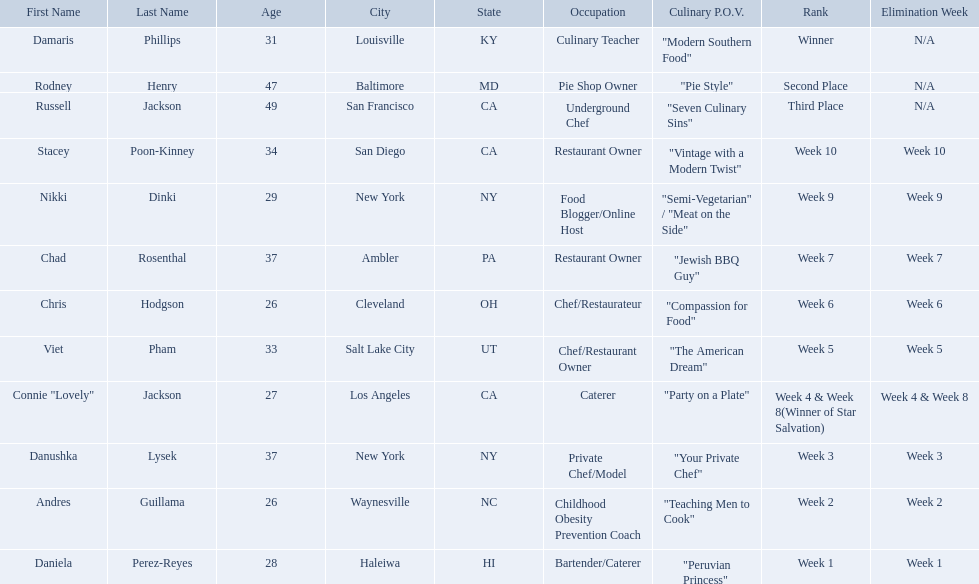Which food network star contestants are in their 20s? Nikki Dinki, Chris Hodgson, Connie "Lovely" Jackson, Andres Guillama, Daniela Perez-Reyes. Of these contestants, which one is the same age as chris hodgson? Andres Guillama. Who are all of the people listed? Damaris Phillips, Rodney Henry, Russell Jackson, Stacey Poon-Kinney, Nikki Dinki, Chad Rosenthal, Chris Hodgson, Viet Pham, Connie "Lovely" Jackson, Danushka Lysek, Andres Guillama, Daniela Perez-Reyes. How old are they? 31, 47, 49, 34, 29, 37, 26, 33, 27, 37, 26, 28. Along with chris hodgson, which other person is 26 years old? Andres Guillama. Who are the contestants? Damaris Phillips, 31, Rodney Henry, 47, Russell Jackson, 49, Stacey Poon-Kinney, 34, Nikki Dinki, 29, Chad Rosenthal, 37, Chris Hodgson, 26, Viet Pham, 33, Connie "Lovely" Jackson, 27, Danushka Lysek, 37, Andres Guillama, 26, Daniela Perez-Reyes, 28. How old is chris hodgson? 26. Which other contestant has that age? Andres Guillama. Who are all of the contestants? Damaris Phillips, Rodney Henry, Russell Jackson, Stacey Poon-Kinney, Nikki Dinki, Chad Rosenthal, Chris Hodgson, Viet Pham, Connie "Lovely" Jackson, Danushka Lysek, Andres Guillama, Daniela Perez-Reyes. What is each player's culinary point of view? "Modern Southern Food", "Pie Style", "Seven Culinary Sins", "Vintage with a Modern Twist", "Semi-Vegetarian" / "Meat on the Side", "Jewish BBQ Guy", "Compassion for Food", "The American Dream", "Party on a Plate", "Your Private Chef", "Teaching Men to Cook", "Peruvian Princess". And which player's point of view is the longest? Nikki Dinki. Who are the listed food network star contestants? Damaris Phillips, Rodney Henry, Russell Jackson, Stacey Poon-Kinney, Nikki Dinki, Chad Rosenthal, Chris Hodgson, Viet Pham, Connie "Lovely" Jackson, Danushka Lysek, Andres Guillama, Daniela Perez-Reyes. Of those who had the longest p.o.v title? Nikki Dinki. Could you help me parse every detail presented in this table? {'header': ['First Name', 'Last Name', 'Age', 'City', 'State', 'Occupation', 'Culinary P.O.V.', 'Rank', 'Elimination Week'], 'rows': [['Damaris', 'Phillips', '31', 'Louisville', 'KY', 'Culinary Teacher', '"Modern Southern Food"', 'Winner', 'N/A'], ['Rodney', 'Henry', '47', 'Baltimore', 'MD', 'Pie Shop Owner', '"Pie Style"', 'Second Place', 'N/A'], ['Russell', 'Jackson', '49', 'San Francisco', 'CA', 'Underground Chef', '"Seven Culinary Sins"', 'Third Place', 'N/A'], ['Stacey', 'Poon-Kinney', '34', 'San Diego', 'CA', 'Restaurant Owner', '"Vintage with a Modern Twist"', 'Week 10', 'Week 10'], ['Nikki', 'Dinki', '29', 'New York', 'NY', 'Food Blogger/Online Host', '"Semi-Vegetarian" / "Meat on the Side"', 'Week 9', 'Week 9'], ['Chad', 'Rosenthal', '37', 'Ambler', 'PA', 'Restaurant Owner', '"Jewish BBQ Guy"', 'Week 7', 'Week 7'], ['Chris', 'Hodgson', '26', 'Cleveland', 'OH', 'Chef/Restaurateur', '"Compassion for Food"', 'Week 6', 'Week 6'], ['Viet', 'Pham', '33', 'Salt Lake City', 'UT', 'Chef/Restaurant Owner', '"The American Dream"', 'Week 5', 'Week 5'], ['Connie "Lovely"', 'Jackson', '27', 'Los Angeles', 'CA', 'Caterer', '"Party on a Plate"', 'Week 4 & Week 8(Winner of Star Salvation)', 'Week 4 & Week 8'], ['Danushka', 'Lysek', '37', 'New York', 'NY', 'Private Chef/Model', '"Your Private Chef"', 'Week 3', 'Week 3'], ['Andres', 'Guillama', '26', 'Waynesville', 'NC', 'Childhood Obesity Prevention Coach', '"Teaching Men to Cook"', 'Week 2', 'Week 2'], ['Daniela', 'Perez-Reyes', '28', 'Haleiwa', 'HI', 'Bartender/Caterer', '"Peruvian Princess"', 'Week 1', 'Week 1']]} 